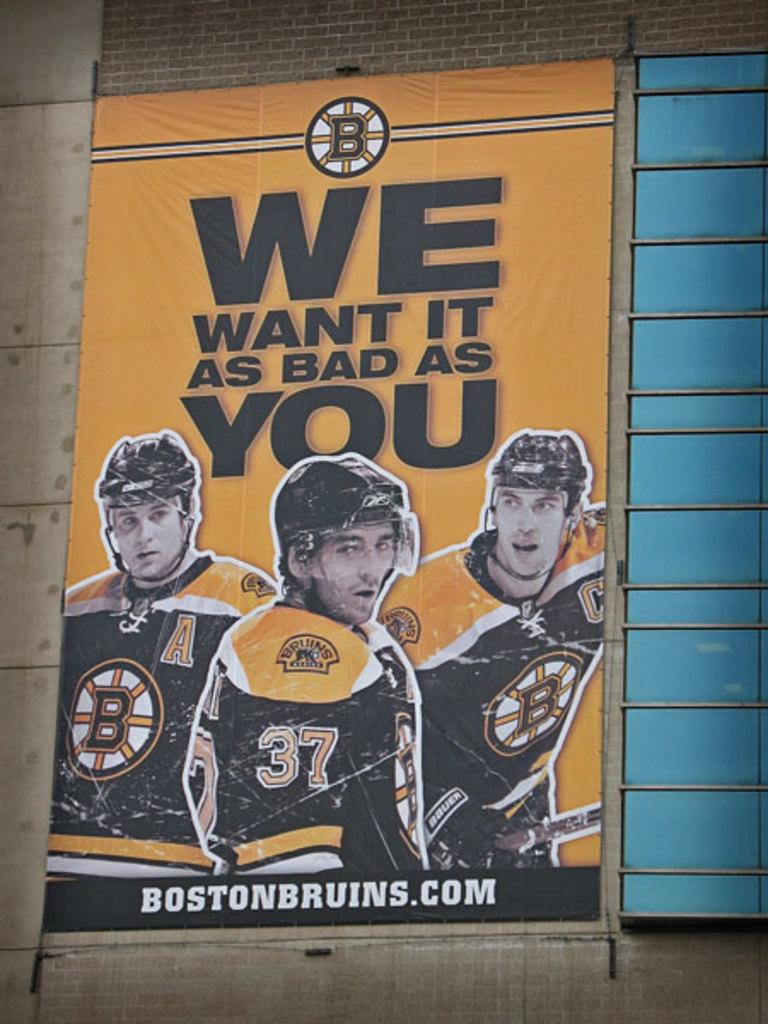<image>
Relay a brief, clear account of the picture shown. Hockey poster telling people we want is as bad as you. 